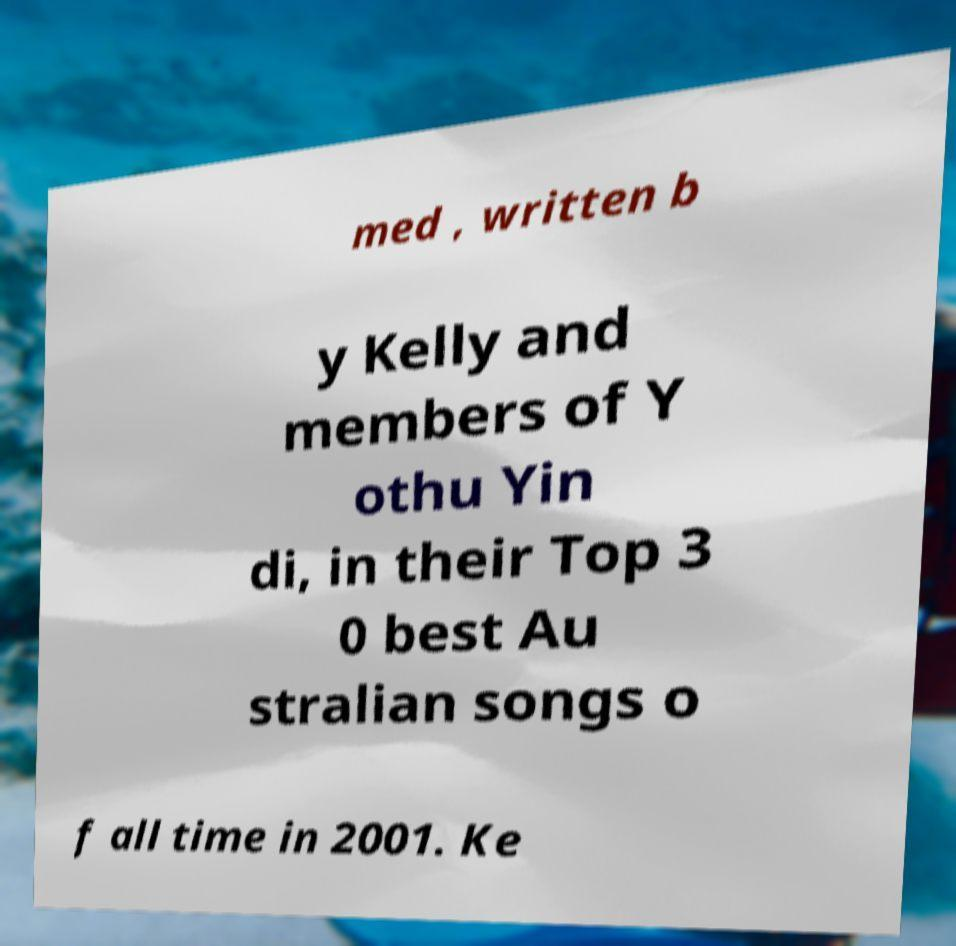Can you read and provide the text displayed in the image?This photo seems to have some interesting text. Can you extract and type it out for me? med , written b y Kelly and members of Y othu Yin di, in their Top 3 0 best Au stralian songs o f all time in 2001. Ke 